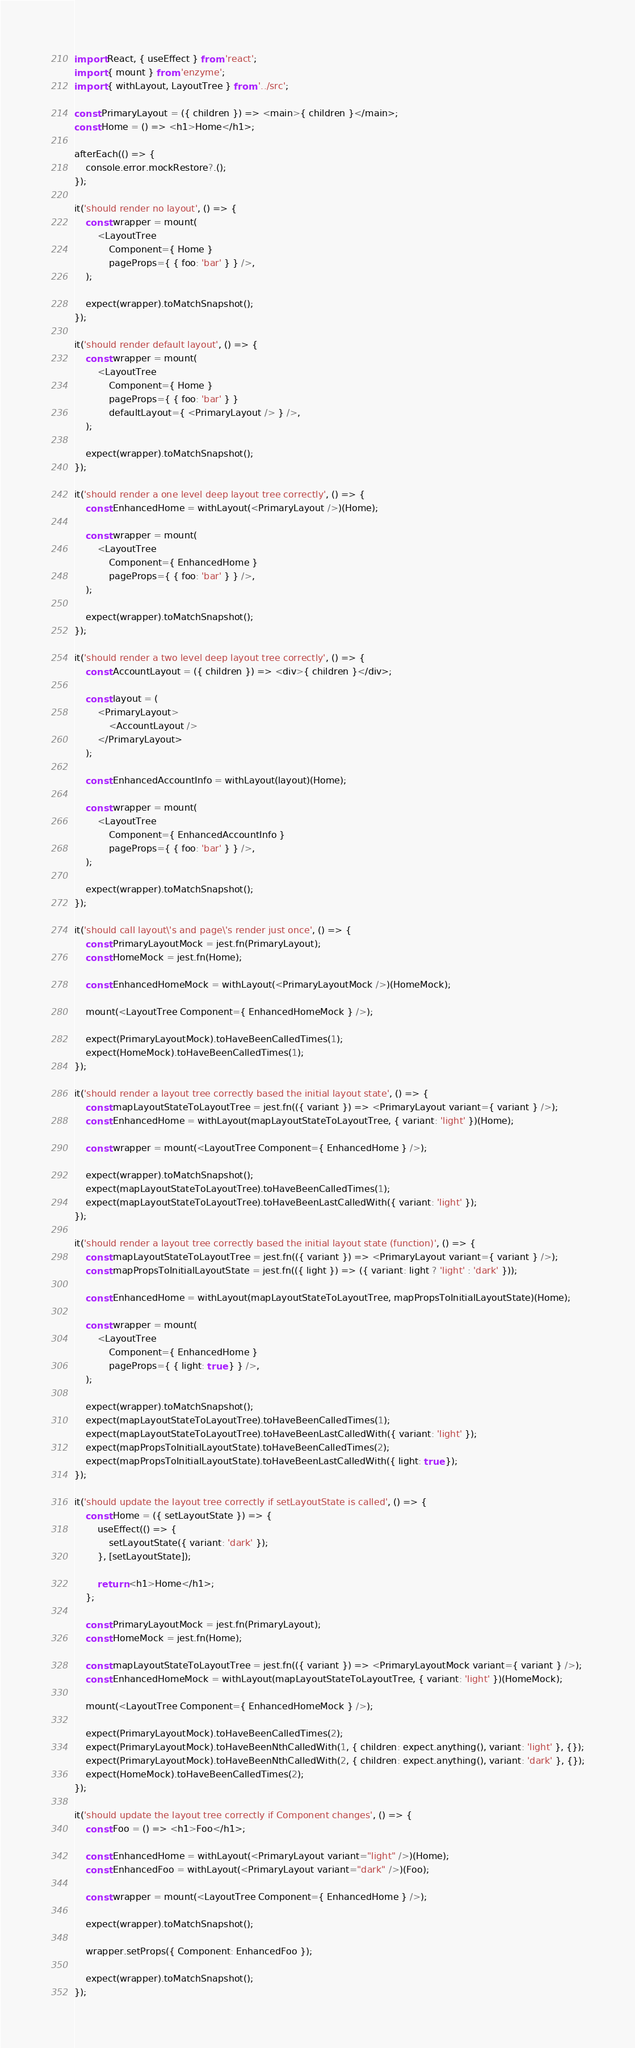<code> <loc_0><loc_0><loc_500><loc_500><_JavaScript_>import React, { useEffect } from 'react';
import { mount } from 'enzyme';
import { withLayout, LayoutTree } from '../src';

const PrimaryLayout = ({ children }) => <main>{ children }</main>;
const Home = () => <h1>Home</h1>;

afterEach(() => {
    console.error.mockRestore?.();
});

it('should render no layout', () => {
    const wrapper = mount(
        <LayoutTree
            Component={ Home }
            pageProps={ { foo: 'bar' } } />,
    );

    expect(wrapper).toMatchSnapshot();
});

it('should render default layout', () => {
    const wrapper = mount(
        <LayoutTree
            Component={ Home }
            pageProps={ { foo: 'bar' } }
            defaultLayout={ <PrimaryLayout /> } />,
    );

    expect(wrapper).toMatchSnapshot();
});

it('should render a one level deep layout tree correctly', () => {
    const EnhancedHome = withLayout(<PrimaryLayout />)(Home);

    const wrapper = mount(
        <LayoutTree
            Component={ EnhancedHome }
            pageProps={ { foo: 'bar' } } />,
    );

    expect(wrapper).toMatchSnapshot();
});

it('should render a two level deep layout tree correctly', () => {
    const AccountLayout = ({ children }) => <div>{ children }</div>;

    const layout = (
        <PrimaryLayout>
            <AccountLayout />
        </PrimaryLayout>
    );

    const EnhancedAccountInfo = withLayout(layout)(Home);

    const wrapper = mount(
        <LayoutTree
            Component={ EnhancedAccountInfo }
            pageProps={ { foo: 'bar' } } />,
    );

    expect(wrapper).toMatchSnapshot();
});

it('should call layout\'s and page\'s render just once', () => {
    const PrimaryLayoutMock = jest.fn(PrimaryLayout);
    const HomeMock = jest.fn(Home);

    const EnhancedHomeMock = withLayout(<PrimaryLayoutMock />)(HomeMock);

    mount(<LayoutTree Component={ EnhancedHomeMock } />);

    expect(PrimaryLayoutMock).toHaveBeenCalledTimes(1);
    expect(HomeMock).toHaveBeenCalledTimes(1);
});

it('should render a layout tree correctly based the initial layout state', () => {
    const mapLayoutStateToLayoutTree = jest.fn(({ variant }) => <PrimaryLayout variant={ variant } />);
    const EnhancedHome = withLayout(mapLayoutStateToLayoutTree, { variant: 'light' })(Home);

    const wrapper = mount(<LayoutTree Component={ EnhancedHome } />);

    expect(wrapper).toMatchSnapshot();
    expect(mapLayoutStateToLayoutTree).toHaveBeenCalledTimes(1);
    expect(mapLayoutStateToLayoutTree).toHaveBeenLastCalledWith({ variant: 'light' });
});

it('should render a layout tree correctly based the initial layout state (function)', () => {
    const mapLayoutStateToLayoutTree = jest.fn(({ variant }) => <PrimaryLayout variant={ variant } />);
    const mapPropsToInitialLayoutState = jest.fn(({ light }) => ({ variant: light ? 'light' : 'dark' }));

    const EnhancedHome = withLayout(mapLayoutStateToLayoutTree, mapPropsToInitialLayoutState)(Home);

    const wrapper = mount(
        <LayoutTree
            Component={ EnhancedHome }
            pageProps={ { light: true } } />,
    );

    expect(wrapper).toMatchSnapshot();
    expect(mapLayoutStateToLayoutTree).toHaveBeenCalledTimes(1);
    expect(mapLayoutStateToLayoutTree).toHaveBeenLastCalledWith({ variant: 'light' });
    expect(mapPropsToInitialLayoutState).toHaveBeenCalledTimes(2);
    expect(mapPropsToInitialLayoutState).toHaveBeenLastCalledWith({ light: true });
});

it('should update the layout tree correctly if setLayoutState is called', () => {
    const Home = ({ setLayoutState }) => {
        useEffect(() => {
            setLayoutState({ variant: 'dark' });
        }, [setLayoutState]);

        return <h1>Home</h1>;
    };

    const PrimaryLayoutMock = jest.fn(PrimaryLayout);
    const HomeMock = jest.fn(Home);

    const mapLayoutStateToLayoutTree = jest.fn(({ variant }) => <PrimaryLayoutMock variant={ variant } />);
    const EnhancedHomeMock = withLayout(mapLayoutStateToLayoutTree, { variant: 'light' })(HomeMock);

    mount(<LayoutTree Component={ EnhancedHomeMock } />);

    expect(PrimaryLayoutMock).toHaveBeenCalledTimes(2);
    expect(PrimaryLayoutMock).toHaveBeenNthCalledWith(1, { children: expect.anything(), variant: 'light' }, {});
    expect(PrimaryLayoutMock).toHaveBeenNthCalledWith(2, { children: expect.anything(), variant: 'dark' }, {});
    expect(HomeMock).toHaveBeenCalledTimes(2);
});

it('should update the layout tree correctly if Component changes', () => {
    const Foo = () => <h1>Foo</h1>;

    const EnhancedHome = withLayout(<PrimaryLayout variant="light" />)(Home);
    const EnhancedFoo = withLayout(<PrimaryLayout variant="dark" />)(Foo);

    const wrapper = mount(<LayoutTree Component={ EnhancedHome } />);

    expect(wrapper).toMatchSnapshot();

    wrapper.setProps({ Component: EnhancedFoo });

    expect(wrapper).toMatchSnapshot();
});
</code> 